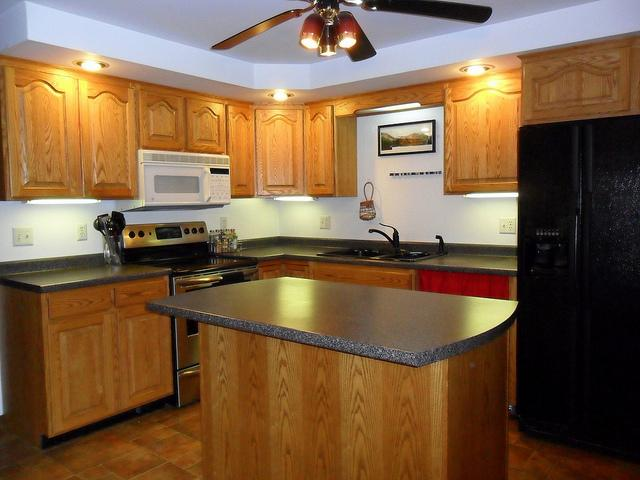What might a person make on the black and silver item on the back left? Please explain your reasoning. food. There is a compartment for cooking hot edible items. the top can be used to fry edibles items. 